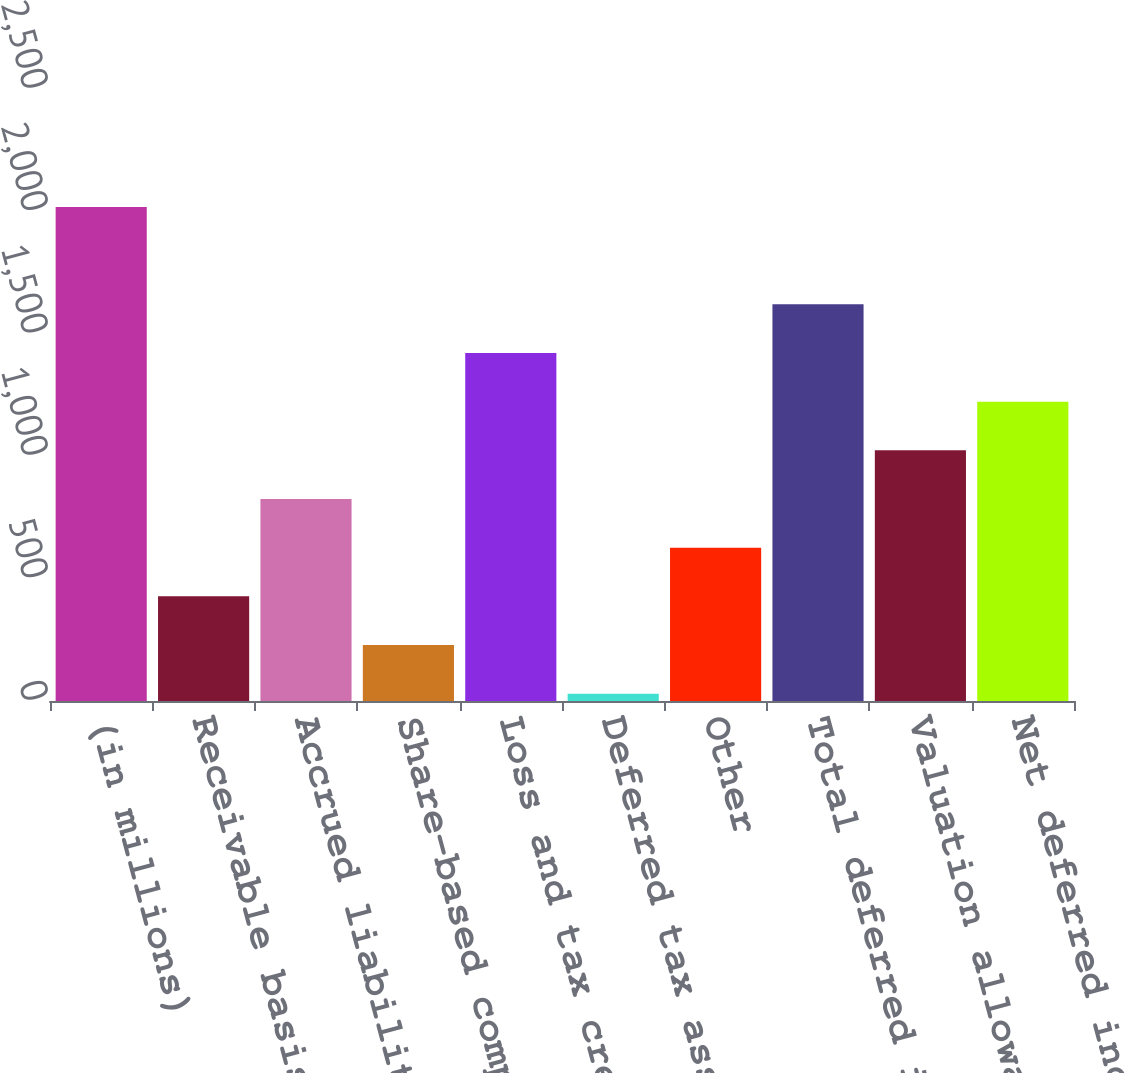Convert chart to OTSL. <chart><loc_0><loc_0><loc_500><loc_500><bar_chart><fcel>(in millions)<fcel>Receivable basis difference<fcel>Accrued liabilities<fcel>Share-based compensation<fcel>Loss and tax credit<fcel>Deferred tax assets related to<fcel>Other<fcel>Total deferred income tax<fcel>Valuation allowance for<fcel>Net deferred income tax assets<nl><fcel>2018<fcel>427.6<fcel>825.2<fcel>228.8<fcel>1421.6<fcel>30<fcel>626.4<fcel>1620.4<fcel>1024<fcel>1222.8<nl></chart> 